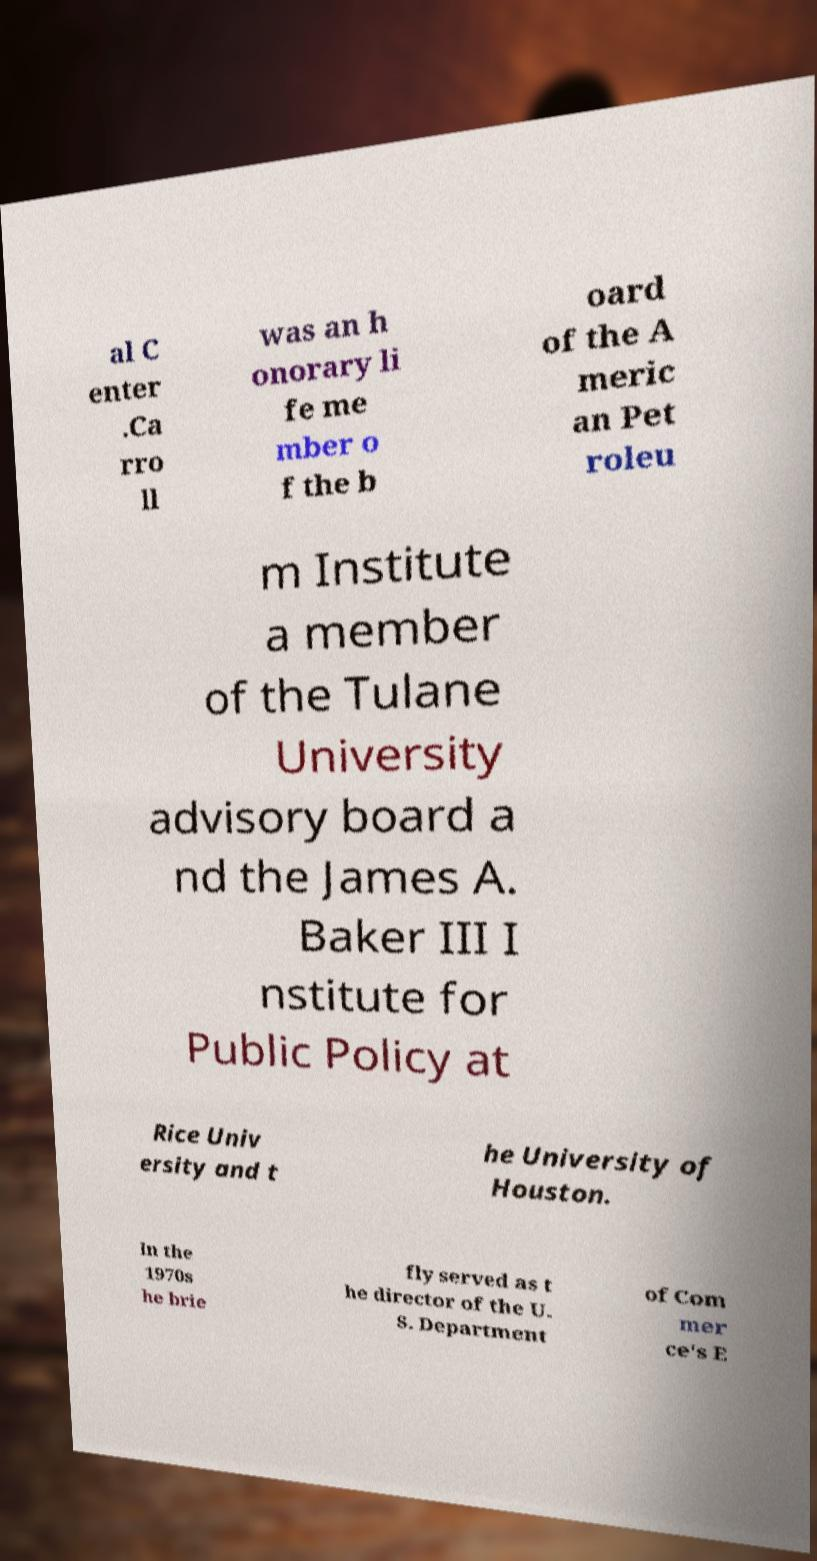Please read and relay the text visible in this image. What does it say? al C enter .Ca rro ll was an h onorary li fe me mber o f the b oard of the A meric an Pet roleu m Institute a member of the Tulane University advisory board a nd the James A. Baker III I nstitute for Public Policy at Rice Univ ersity and t he University of Houston. In the 1970s he brie fly served as t he director of the U. S. Department of Com mer ce's E 